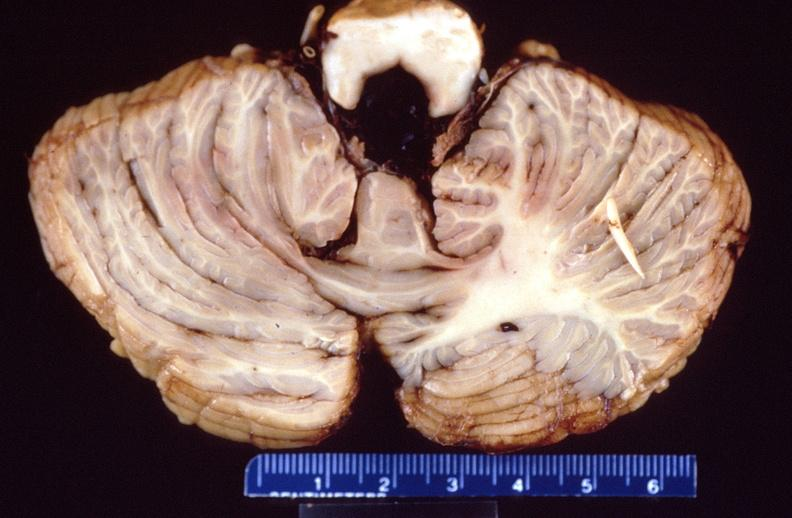does this image show brain, intracerebral hemorrhage?
Answer the question using a single word or phrase. Yes 